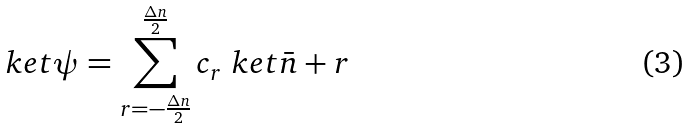Convert formula to latex. <formula><loc_0><loc_0><loc_500><loc_500>\ k e t { \psi } = \sum _ { r = - \frac { \Delta n } { 2 } } ^ { \frac { \Delta n } { 2 } } c _ { r } \ k e t { \bar { n } + r }</formula> 